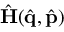<formula> <loc_0><loc_0><loc_500><loc_500>\hat { H } ( \hat { q } , \hat { p } )</formula> 